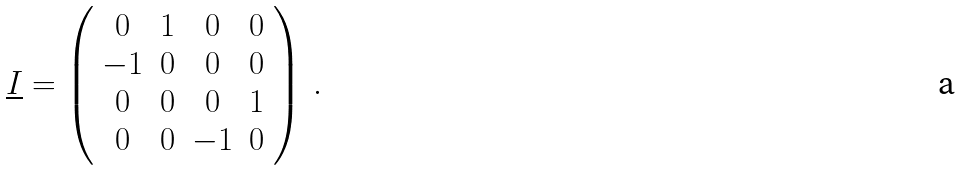Convert formula to latex. <formula><loc_0><loc_0><loc_500><loc_500>\underline { I } = \left ( \begin{array} { c c c c } 0 & 1 & 0 & 0 \\ - 1 & 0 & 0 & 0 \\ 0 & 0 & 0 & 1 \\ 0 & 0 & - 1 & 0 \end{array} \right ) \, .</formula> 